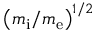<formula> <loc_0><loc_0><loc_500><loc_500>\left ( m _ { i } / m _ { e } \right ) ^ { 1 / 2 }</formula> 